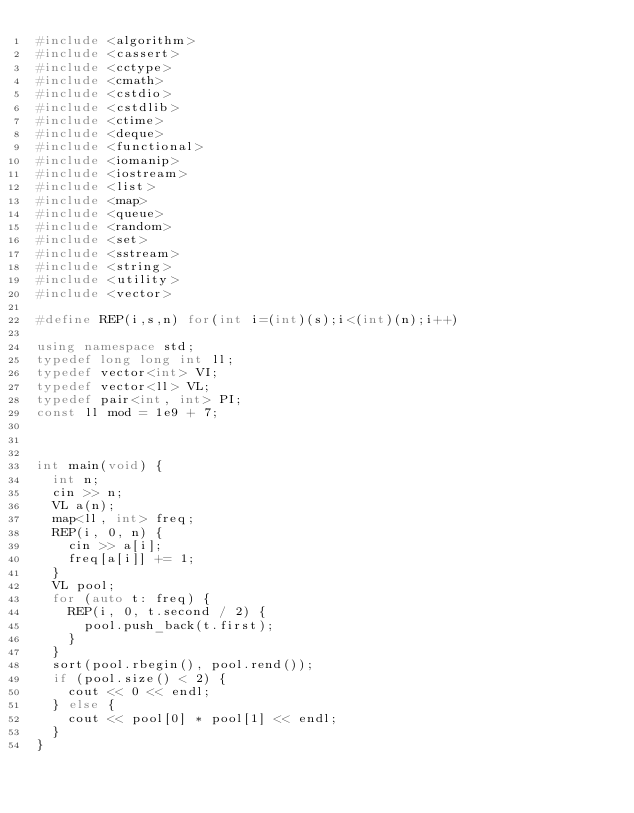<code> <loc_0><loc_0><loc_500><loc_500><_C++_>#include <algorithm>
#include <cassert>
#include <cctype>
#include <cmath>
#include <cstdio>
#include <cstdlib>
#include <ctime>
#include <deque>
#include <functional>
#include <iomanip>
#include <iostream>
#include <list>
#include <map>
#include <queue>
#include <random>
#include <set>
#include <sstream>
#include <string>
#include <utility>
#include <vector>

#define REP(i,s,n) for(int i=(int)(s);i<(int)(n);i++)

using namespace std;
typedef long long int ll;
typedef vector<int> VI;
typedef vector<ll> VL;
typedef pair<int, int> PI;
const ll mod = 1e9 + 7;



int main(void) {
  int n;
  cin >> n;
  VL a(n);
  map<ll, int> freq;
  REP(i, 0, n) {
    cin >> a[i];
    freq[a[i]] += 1;
  }
  VL pool;
  for (auto t: freq) {
    REP(i, 0, t.second / 2) {
      pool.push_back(t.first);
    }
  }
  sort(pool.rbegin(), pool.rend());
  if (pool.size() < 2) {
    cout << 0 << endl;
  } else {
    cout << pool[0] * pool[1] << endl;
  }
}
</code> 